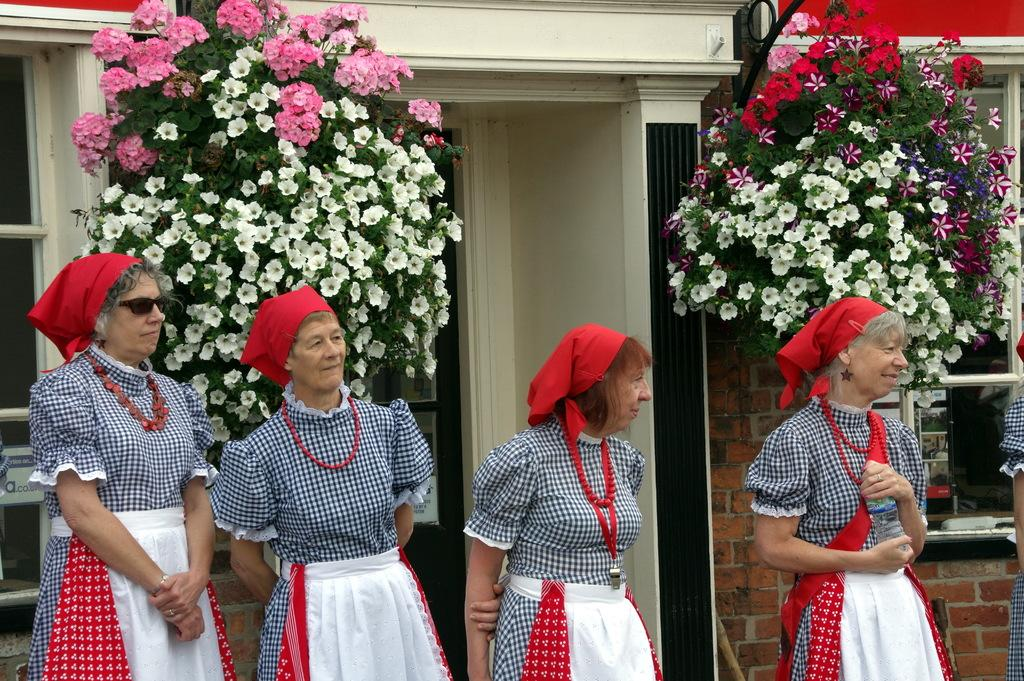How many women are present in the image? There are four women standing in the image. What can be seen in the background of the image? There are plants with colorful flowers in the image, and it appears to depict a house with a window. What are the women wearing in the image? The women are wearing frocks.cks. What is the distinctive feature of their clothing? The women have red-colored clothes on their heads. What type of committee is meeting in the image? There is no committee meeting in the image; it features four women standing near plants with colorful flowers. Can you see a hammer in the image? No, there is no hammer present in the image. 